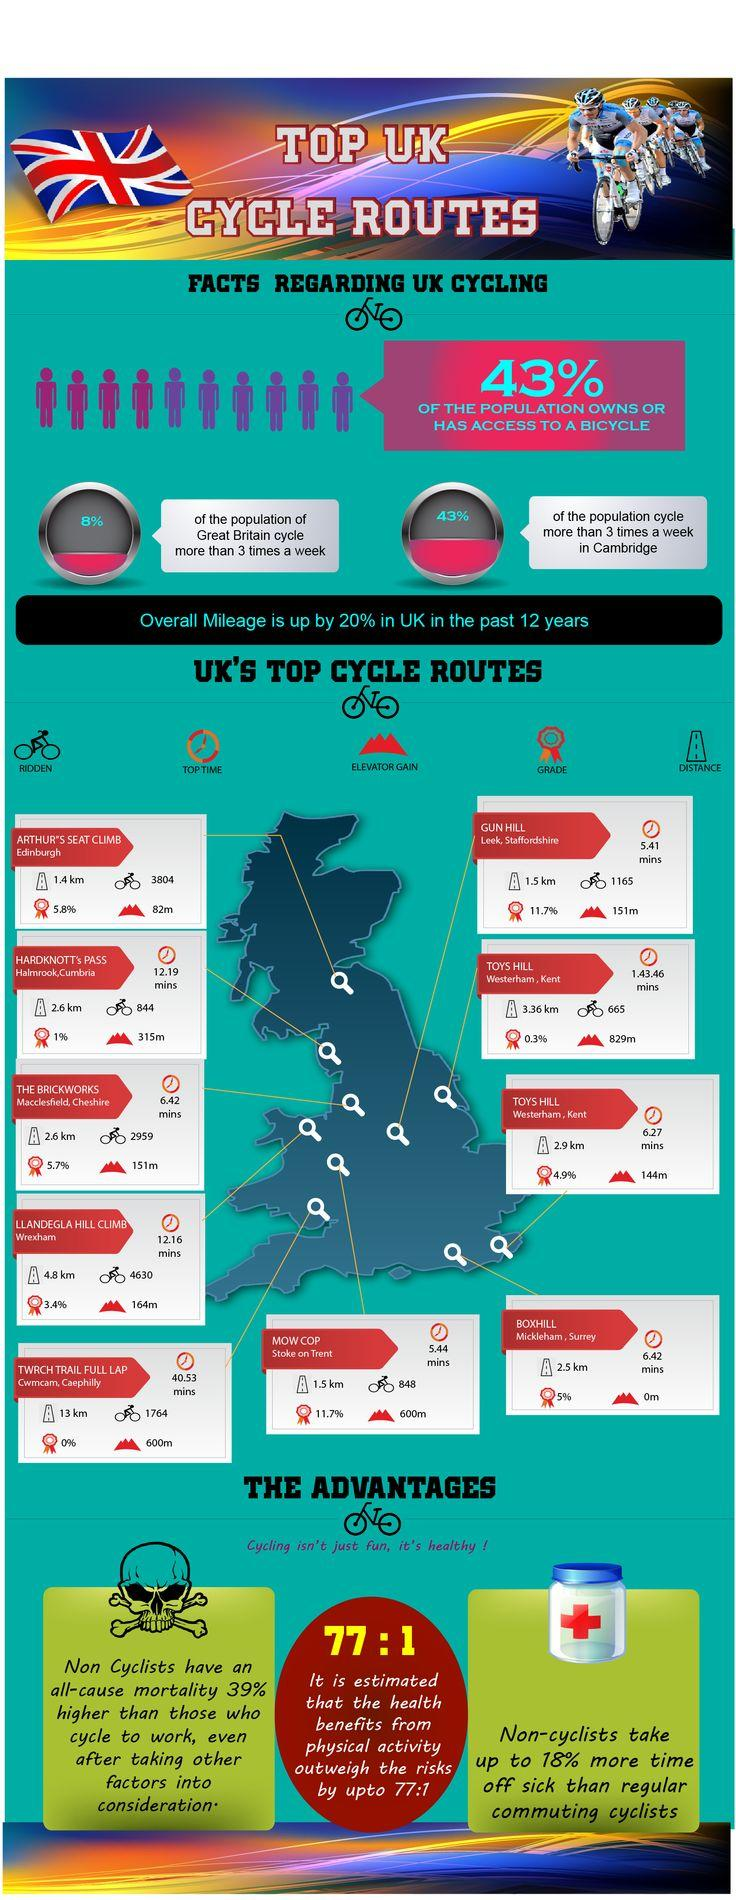List a handful of essential elements in this visual. According to recent studies, approximately 57% of the population does not own or have no access to a bicycle. 